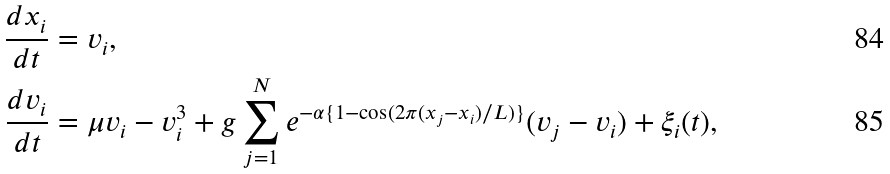Convert formula to latex. <formula><loc_0><loc_0><loc_500><loc_500>\frac { d x _ { i } } { d t } & = v _ { i } , \\ \frac { d v _ { i } } { d t } & = \mu v _ { i } - v _ { i } ^ { 3 } + g \sum _ { j = 1 } ^ { N } e ^ { - \alpha \{ 1 - \cos ( 2 \pi ( x _ { j } - x _ { i } ) / L ) \} } ( v _ { j } - v _ { i } ) + \xi _ { i } ( t ) ,</formula> 